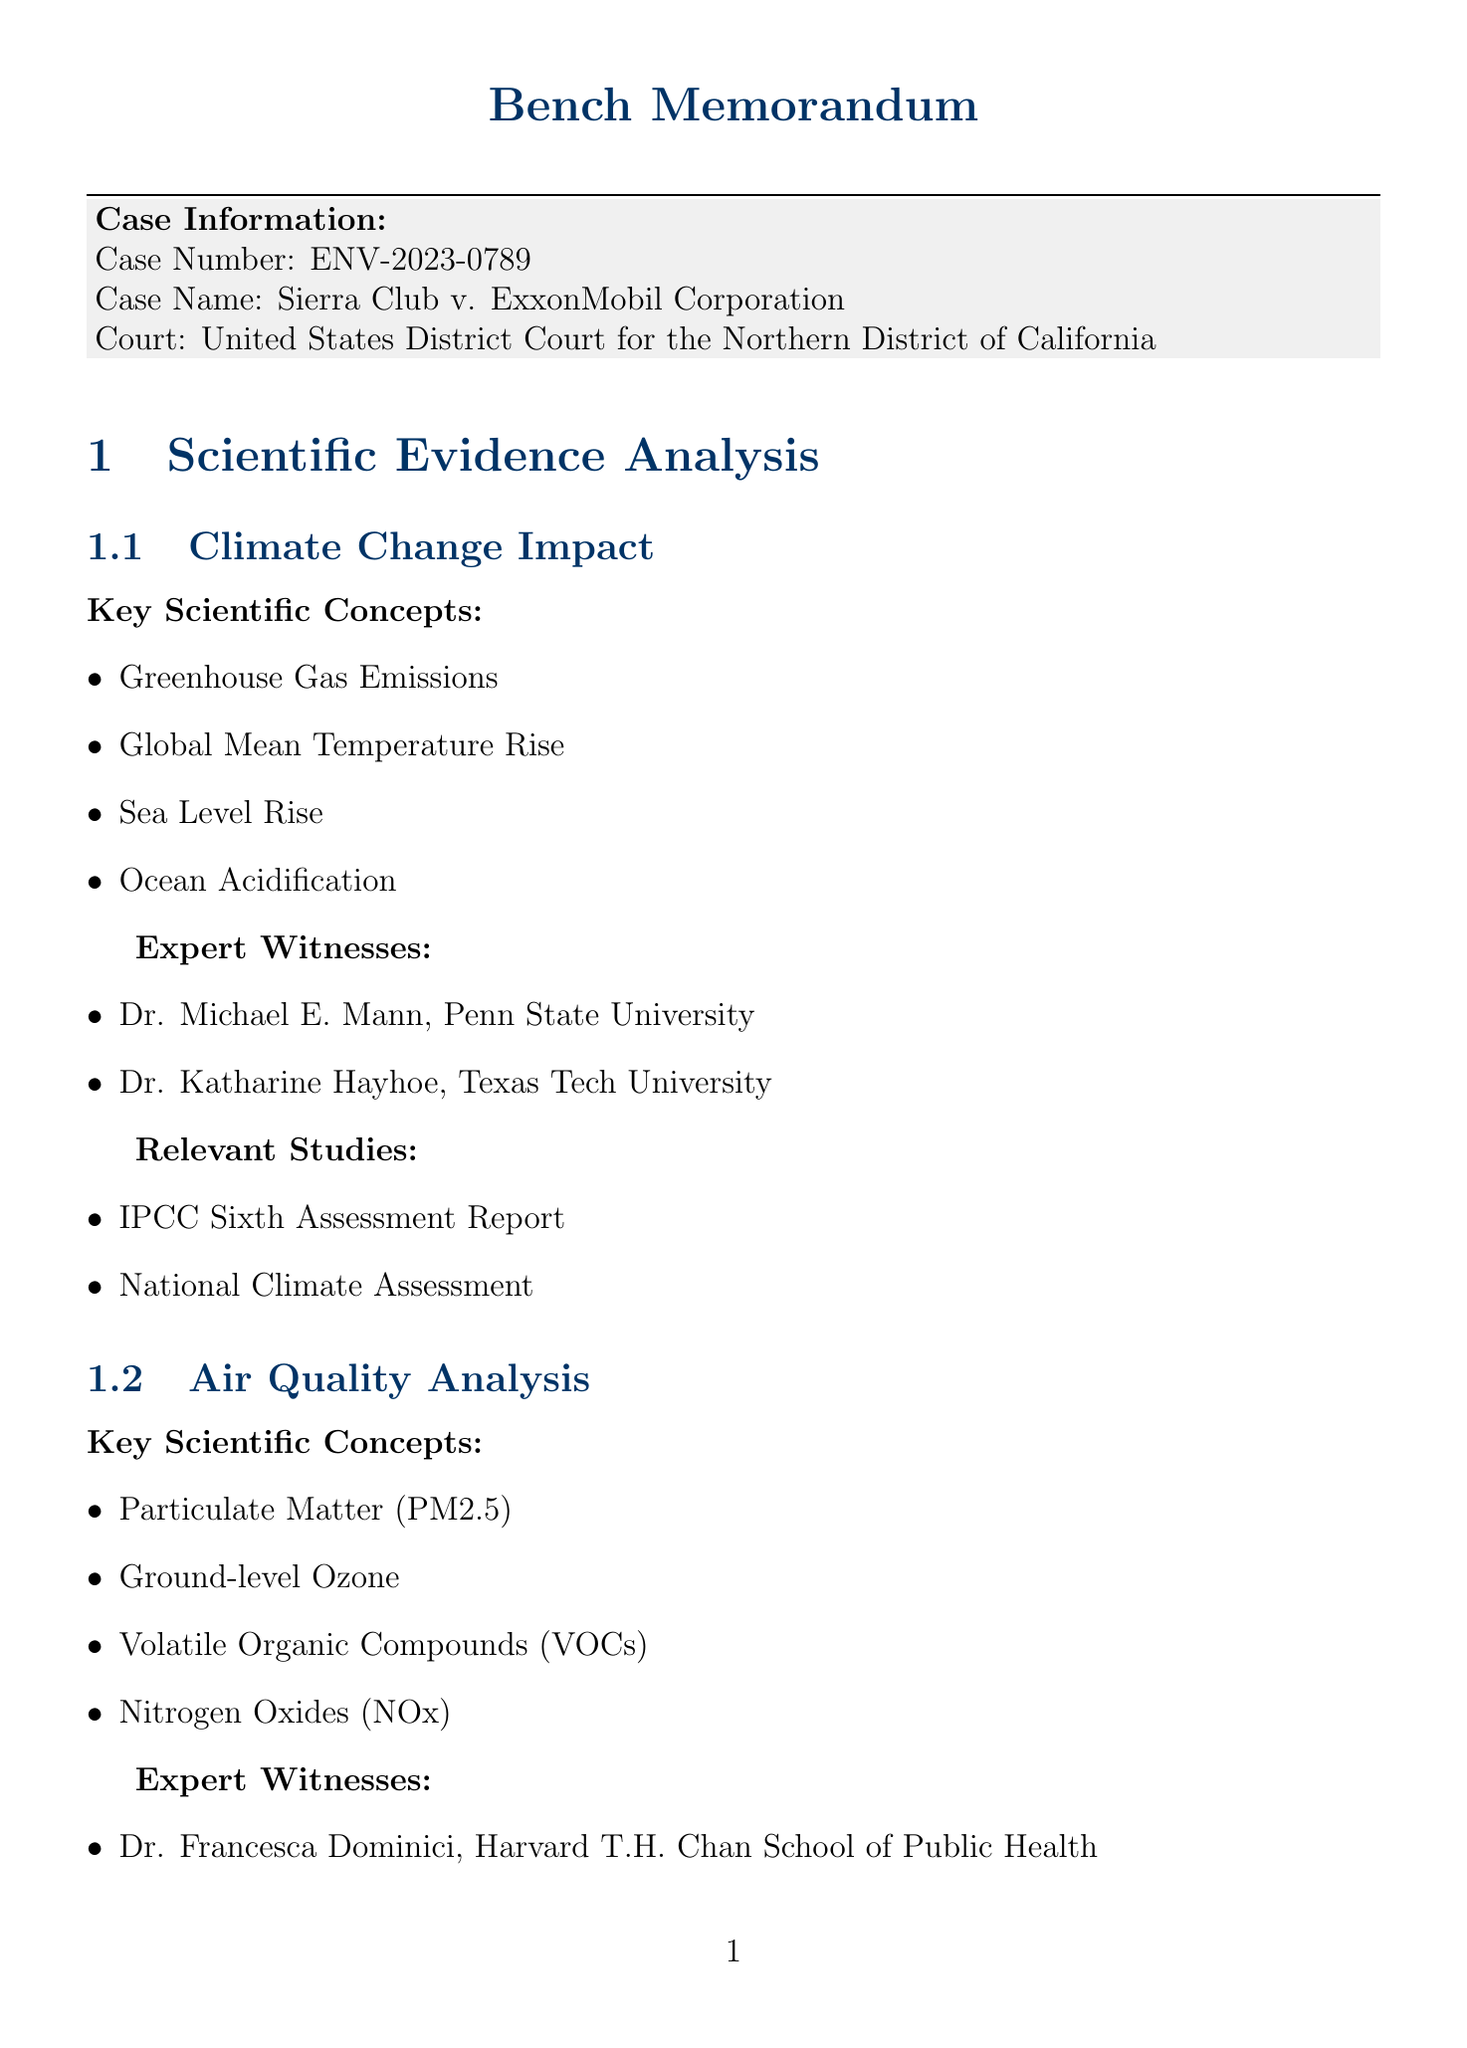What is the case number? The case number is explicitly stated in the document under Case Information.
Answer: ENV-2023-0789 Who are the expert witnesses for Climate Change Impact? The document lists specific expert witnesses under the Climate Change Impact section.
Answer: Dr. Michael E. Mann, Dr. Katharine Hayhoe What is the burden of proof in this case? The burden of proof is mentioned in the Legal Standards section of the document.
Answer: Preponderance of Evidence List one relevant study for Air Quality Analysis. The document includes a list of relevant studies under the Air Quality Analysis section.
Answer: EPA National Ambient Air Quality Standards Review What key scientific concept is related to Biodiversity Loss? The document lists key scientific concepts in the Ecological Impact Assessment section, including Biodiversity Loss.
Answer: Biodiversity Loss Who are the expert witnesses for Ecological Impact Assessment? The document provides names of expert witnesses in the Ecological Impact Assessment section.
Answer: Dr. Stuart Pimm, Dr. Jane Lubchenco What environmental act is relevant to this case? The document specifies relevant statutes in the Legal Standards section, which includes environmental acts.
Answer: Clean Air Act How should conflicting evidence be evaluated according to the judge's notes? The judge's notes provide guidance on evaluating conflicting evidence in the document.
Answer: Evaluate strength of evidence on both sides What is the admissibility criteria mentioned in the document? The admissibility criteria is outlined clearly in the Legal Standards section of the document.
Answer: Daubert Standard 